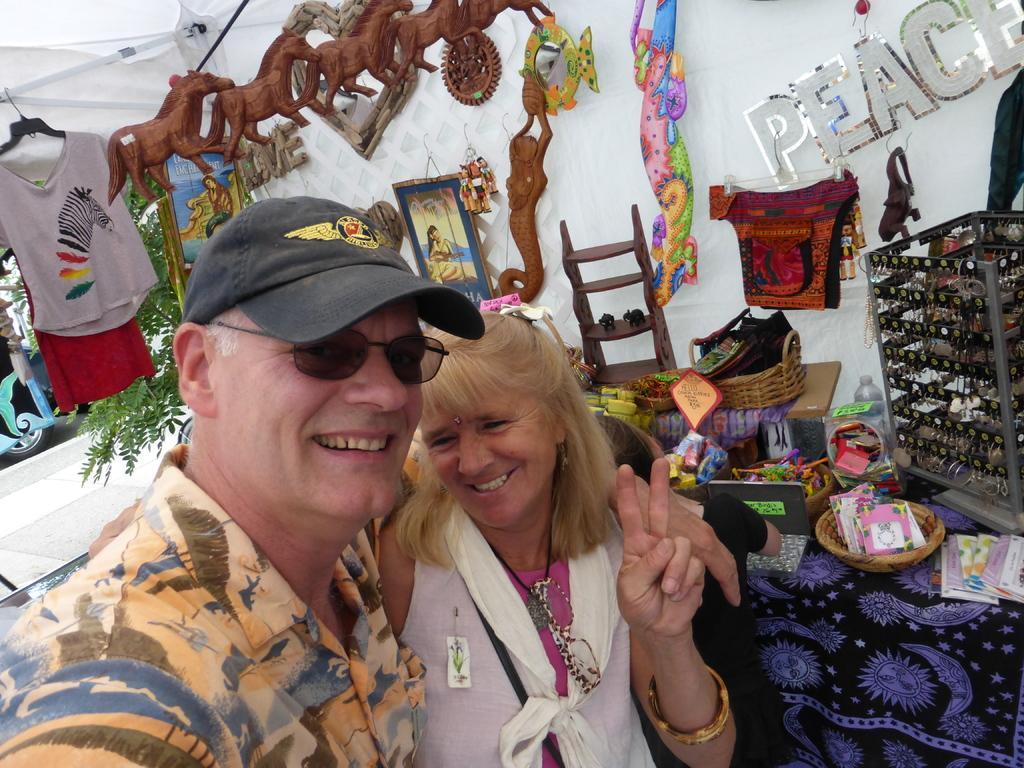How many people are in the image? There are two persons standing in the image. What is the facial expression of the people in the image? Both persons are smiling. Can you describe the clothing of one of the persons? One person is wearing an orange color shirt. What type of objects can be seen in the image? There are toys and some objects in the image. What is the natural element present in the image? There is a tree in the image. Can you see any clover growing near the tree in the image? There is no clover visible in the image; only a tree is present. What type of school can be seen in the image? There is no school present in the image. 